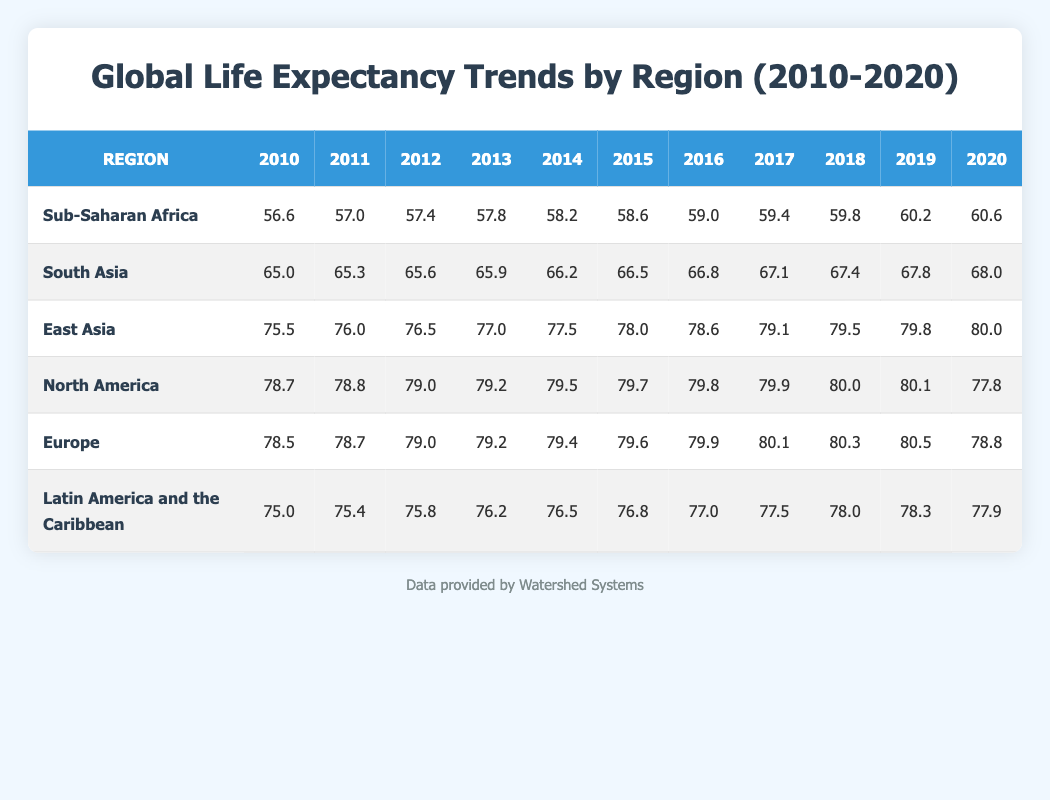What was the life expectancy in Sub-Saharan Africa in 2015? The table shows the life expectancy for Sub-Saharan Africa in 2015, which is listed at 58.6.
Answer: 58.6 What region had the highest life expectancy in 2020? By comparing the life expectancies listed for all regions in 2020, East Asia has the highest life expectancy at 80.0.
Answer: 80.0 What is the average life expectancy for South Asia from 2010 to 2020? The life expectancies for South Asia from 2010 to 2020 are: 65.0, 65.3, 65.6, 65.9, 66.2, 66.5, 66.8, 67.1, 67.4, 67.8, 68.0. Summing these values gives 734.6. There are 11 values, so the average is 734.6 / 11 = 66.78.
Answer: 66.78 Did North America experience a decline in life expectancy between 2019 and 2020? The life expectancy for North America in 2019 is 80.1 and in 2020 it is 77.8. Since 77.8 is less than 80.1, this confirms a decline.
Answer: Yes What was the increase in life expectancy in Latin America and the Caribbean from 2010 to 2020? The life expectancy in Latin America and the Caribbean increased from 75.0 in 2010 to 77.9 in 2020. To find the increase, subtract 75.0 from 77.9: 77.9 - 75.0 = 2.9.
Answer: 2.9 Which two regions had the closest life expectancy in 2018? In 2018, the life expectations for regions are: Latin America and the Caribbean (78.0) and Europe (80.3). The difference is 80.3 - 78.0 which equals 2.3. Therefore, these two regions had the closest life expectancy.
Answer: 2.3 What was the highest life expectancy recorded in North America during the period? The table shows North America had a peak life expectancy of 80.1 in 2019.
Answer: 80.1 How much did life expectancy in East Asia increase from 2010 to 2020? The life expectancy increased from 75.5 in 2010 to 80.0 in 2020. The increase is 80.0 - 75.5 = 4.5.
Answer: 4.5 Was the life expectancy in Europe higher than that in Sub-Saharan Africa in 2019? In 2019, Europe had a life expectancy of 80.5 while Sub-Saharan Africa had 60.2. Since 80.5 is greater than 60.2, this is true.
Answer: Yes 